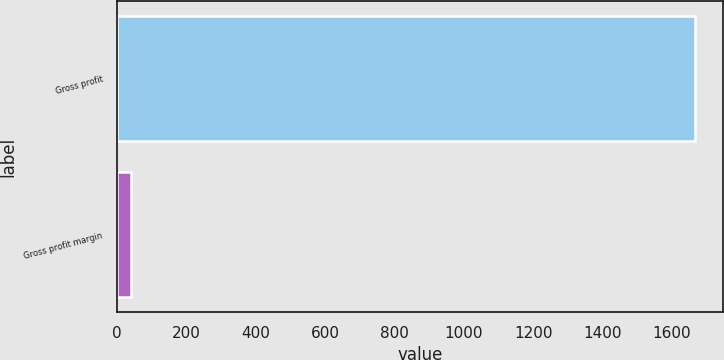Convert chart. <chart><loc_0><loc_0><loc_500><loc_500><bar_chart><fcel>Gross profit<fcel>Gross profit margin<nl><fcel>1665.8<fcel>40.4<nl></chart> 